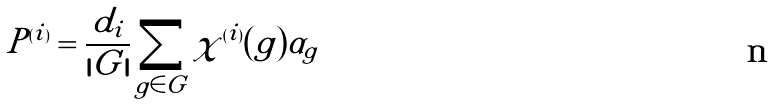<formula> <loc_0><loc_0><loc_500><loc_500>P ^ { ( i ) } = { \frac { d _ { i } } { | G | } } \sum _ { g \in G } \chi ^ { ( i ) } ( g ) \alpha _ { g }</formula> 